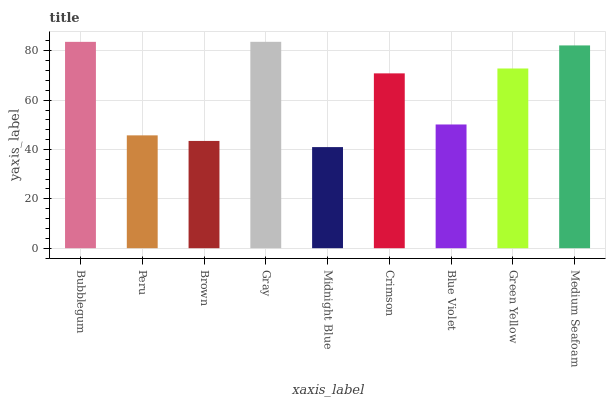Is Midnight Blue the minimum?
Answer yes or no. Yes. Is Gray the maximum?
Answer yes or no. Yes. Is Peru the minimum?
Answer yes or no. No. Is Peru the maximum?
Answer yes or no. No. Is Bubblegum greater than Peru?
Answer yes or no. Yes. Is Peru less than Bubblegum?
Answer yes or no. Yes. Is Peru greater than Bubblegum?
Answer yes or no. No. Is Bubblegum less than Peru?
Answer yes or no. No. Is Crimson the high median?
Answer yes or no. Yes. Is Crimson the low median?
Answer yes or no. Yes. Is Blue Violet the high median?
Answer yes or no. No. Is Bubblegum the low median?
Answer yes or no. No. 